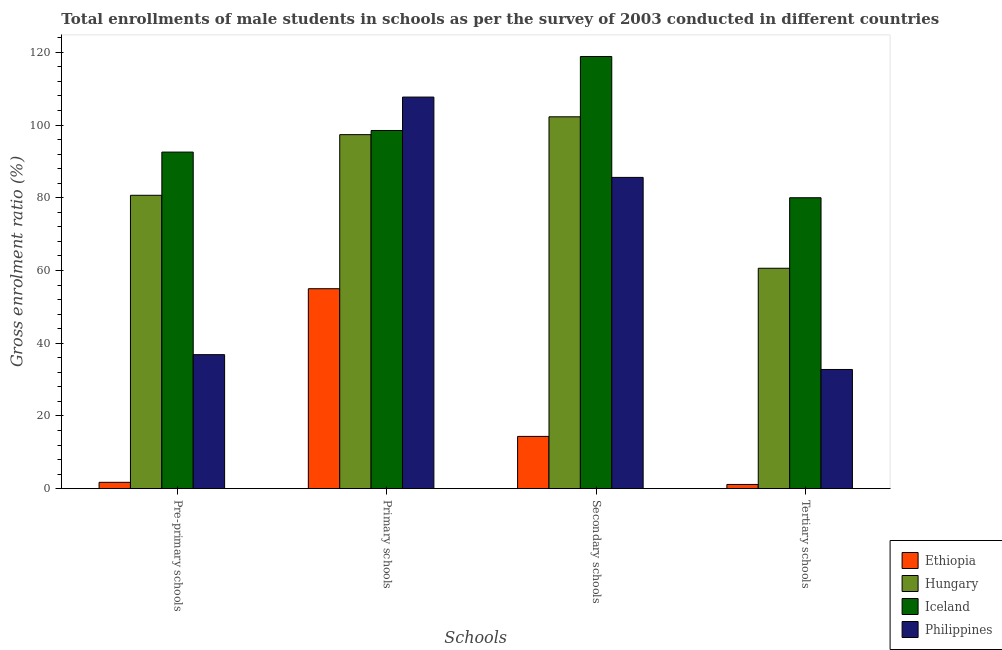Are the number of bars per tick equal to the number of legend labels?
Give a very brief answer. Yes. Are the number of bars on each tick of the X-axis equal?
Offer a very short reply. Yes. How many bars are there on the 3rd tick from the left?
Your answer should be very brief. 4. What is the label of the 1st group of bars from the left?
Make the answer very short. Pre-primary schools. What is the gross enrolment ratio(male) in secondary schools in Philippines?
Offer a very short reply. 85.6. Across all countries, what is the maximum gross enrolment ratio(male) in primary schools?
Ensure brevity in your answer.  107.69. Across all countries, what is the minimum gross enrolment ratio(male) in pre-primary schools?
Keep it short and to the point. 1.75. In which country was the gross enrolment ratio(male) in secondary schools maximum?
Give a very brief answer. Iceland. In which country was the gross enrolment ratio(male) in tertiary schools minimum?
Offer a terse response. Ethiopia. What is the total gross enrolment ratio(male) in primary schools in the graph?
Provide a short and direct response. 358.55. What is the difference between the gross enrolment ratio(male) in secondary schools in Ethiopia and that in Philippines?
Offer a very short reply. -71.23. What is the difference between the gross enrolment ratio(male) in secondary schools in Philippines and the gross enrolment ratio(male) in pre-primary schools in Iceland?
Keep it short and to the point. -6.96. What is the average gross enrolment ratio(male) in secondary schools per country?
Provide a succinct answer. 80.28. What is the difference between the gross enrolment ratio(male) in tertiary schools and gross enrolment ratio(male) in primary schools in Philippines?
Keep it short and to the point. -74.91. In how many countries, is the gross enrolment ratio(male) in primary schools greater than 72 %?
Your answer should be very brief. 3. What is the ratio of the gross enrolment ratio(male) in primary schools in Philippines to that in Iceland?
Provide a short and direct response. 1.09. Is the difference between the gross enrolment ratio(male) in tertiary schools in Ethiopia and Hungary greater than the difference between the gross enrolment ratio(male) in secondary schools in Ethiopia and Hungary?
Provide a short and direct response. Yes. What is the difference between the highest and the second highest gross enrolment ratio(male) in primary schools?
Your response must be concise. 9.19. What is the difference between the highest and the lowest gross enrolment ratio(male) in tertiary schools?
Ensure brevity in your answer.  78.85. What does the 2nd bar from the left in Pre-primary schools represents?
Make the answer very short. Hungary. What does the 1st bar from the right in Primary schools represents?
Ensure brevity in your answer.  Philippines. Is it the case that in every country, the sum of the gross enrolment ratio(male) in pre-primary schools and gross enrolment ratio(male) in primary schools is greater than the gross enrolment ratio(male) in secondary schools?
Your response must be concise. Yes. How many bars are there?
Keep it short and to the point. 16. Are all the bars in the graph horizontal?
Give a very brief answer. No. What is the difference between two consecutive major ticks on the Y-axis?
Your answer should be very brief. 20. Does the graph contain any zero values?
Offer a terse response. No. What is the title of the graph?
Offer a very short reply. Total enrollments of male students in schools as per the survey of 2003 conducted in different countries. Does "Uruguay" appear as one of the legend labels in the graph?
Offer a terse response. No. What is the label or title of the X-axis?
Provide a short and direct response. Schools. What is the label or title of the Y-axis?
Provide a succinct answer. Gross enrolment ratio (%). What is the Gross enrolment ratio (%) in Ethiopia in Pre-primary schools?
Your answer should be compact. 1.75. What is the Gross enrolment ratio (%) in Hungary in Pre-primary schools?
Provide a short and direct response. 80.68. What is the Gross enrolment ratio (%) of Iceland in Pre-primary schools?
Ensure brevity in your answer.  92.56. What is the Gross enrolment ratio (%) in Philippines in Pre-primary schools?
Keep it short and to the point. 36.86. What is the Gross enrolment ratio (%) in Ethiopia in Primary schools?
Ensure brevity in your answer.  54.99. What is the Gross enrolment ratio (%) in Hungary in Primary schools?
Make the answer very short. 97.36. What is the Gross enrolment ratio (%) of Iceland in Primary schools?
Offer a terse response. 98.51. What is the Gross enrolment ratio (%) in Philippines in Primary schools?
Make the answer very short. 107.69. What is the Gross enrolment ratio (%) in Ethiopia in Secondary schools?
Make the answer very short. 14.38. What is the Gross enrolment ratio (%) of Hungary in Secondary schools?
Your answer should be compact. 102.27. What is the Gross enrolment ratio (%) in Iceland in Secondary schools?
Offer a terse response. 118.85. What is the Gross enrolment ratio (%) of Philippines in Secondary schools?
Make the answer very short. 85.6. What is the Gross enrolment ratio (%) of Ethiopia in Tertiary schools?
Make the answer very short. 1.16. What is the Gross enrolment ratio (%) in Hungary in Tertiary schools?
Keep it short and to the point. 60.61. What is the Gross enrolment ratio (%) in Iceland in Tertiary schools?
Provide a succinct answer. 80.01. What is the Gross enrolment ratio (%) in Philippines in Tertiary schools?
Offer a very short reply. 32.78. Across all Schools, what is the maximum Gross enrolment ratio (%) of Ethiopia?
Your answer should be compact. 54.99. Across all Schools, what is the maximum Gross enrolment ratio (%) of Hungary?
Offer a terse response. 102.27. Across all Schools, what is the maximum Gross enrolment ratio (%) of Iceland?
Your answer should be very brief. 118.85. Across all Schools, what is the maximum Gross enrolment ratio (%) in Philippines?
Offer a terse response. 107.69. Across all Schools, what is the minimum Gross enrolment ratio (%) of Ethiopia?
Your answer should be compact. 1.16. Across all Schools, what is the minimum Gross enrolment ratio (%) in Hungary?
Keep it short and to the point. 60.61. Across all Schools, what is the minimum Gross enrolment ratio (%) of Iceland?
Provide a short and direct response. 80.01. Across all Schools, what is the minimum Gross enrolment ratio (%) of Philippines?
Provide a succinct answer. 32.78. What is the total Gross enrolment ratio (%) of Ethiopia in the graph?
Make the answer very short. 72.27. What is the total Gross enrolment ratio (%) in Hungary in the graph?
Ensure brevity in your answer.  340.92. What is the total Gross enrolment ratio (%) in Iceland in the graph?
Offer a very short reply. 389.93. What is the total Gross enrolment ratio (%) in Philippines in the graph?
Your answer should be compact. 262.94. What is the difference between the Gross enrolment ratio (%) in Ethiopia in Pre-primary schools and that in Primary schools?
Give a very brief answer. -53.24. What is the difference between the Gross enrolment ratio (%) in Hungary in Pre-primary schools and that in Primary schools?
Ensure brevity in your answer.  -16.68. What is the difference between the Gross enrolment ratio (%) of Iceland in Pre-primary schools and that in Primary schools?
Give a very brief answer. -5.94. What is the difference between the Gross enrolment ratio (%) in Philippines in Pre-primary schools and that in Primary schools?
Offer a very short reply. -70.83. What is the difference between the Gross enrolment ratio (%) in Ethiopia in Pre-primary schools and that in Secondary schools?
Offer a very short reply. -12.63. What is the difference between the Gross enrolment ratio (%) in Hungary in Pre-primary schools and that in Secondary schools?
Make the answer very short. -21.58. What is the difference between the Gross enrolment ratio (%) of Iceland in Pre-primary schools and that in Secondary schools?
Provide a succinct answer. -26.29. What is the difference between the Gross enrolment ratio (%) in Philippines in Pre-primary schools and that in Secondary schools?
Provide a succinct answer. -48.74. What is the difference between the Gross enrolment ratio (%) in Ethiopia in Pre-primary schools and that in Tertiary schools?
Provide a succinct answer. 0.59. What is the difference between the Gross enrolment ratio (%) in Hungary in Pre-primary schools and that in Tertiary schools?
Your answer should be very brief. 20.07. What is the difference between the Gross enrolment ratio (%) of Iceland in Pre-primary schools and that in Tertiary schools?
Keep it short and to the point. 12.55. What is the difference between the Gross enrolment ratio (%) in Philippines in Pre-primary schools and that in Tertiary schools?
Give a very brief answer. 4.08. What is the difference between the Gross enrolment ratio (%) in Ethiopia in Primary schools and that in Secondary schools?
Your answer should be very brief. 40.61. What is the difference between the Gross enrolment ratio (%) of Hungary in Primary schools and that in Secondary schools?
Make the answer very short. -4.91. What is the difference between the Gross enrolment ratio (%) in Iceland in Primary schools and that in Secondary schools?
Your response must be concise. -20.35. What is the difference between the Gross enrolment ratio (%) in Philippines in Primary schools and that in Secondary schools?
Your answer should be very brief. 22.09. What is the difference between the Gross enrolment ratio (%) in Ethiopia in Primary schools and that in Tertiary schools?
Offer a terse response. 53.83. What is the difference between the Gross enrolment ratio (%) in Hungary in Primary schools and that in Tertiary schools?
Your answer should be very brief. 36.74. What is the difference between the Gross enrolment ratio (%) of Iceland in Primary schools and that in Tertiary schools?
Ensure brevity in your answer.  18.5. What is the difference between the Gross enrolment ratio (%) in Philippines in Primary schools and that in Tertiary schools?
Offer a very short reply. 74.91. What is the difference between the Gross enrolment ratio (%) of Ethiopia in Secondary schools and that in Tertiary schools?
Provide a short and direct response. 13.22. What is the difference between the Gross enrolment ratio (%) in Hungary in Secondary schools and that in Tertiary schools?
Provide a succinct answer. 41.65. What is the difference between the Gross enrolment ratio (%) of Iceland in Secondary schools and that in Tertiary schools?
Your answer should be very brief. 38.84. What is the difference between the Gross enrolment ratio (%) in Philippines in Secondary schools and that in Tertiary schools?
Give a very brief answer. 52.82. What is the difference between the Gross enrolment ratio (%) in Ethiopia in Pre-primary schools and the Gross enrolment ratio (%) in Hungary in Primary schools?
Your answer should be compact. -95.61. What is the difference between the Gross enrolment ratio (%) in Ethiopia in Pre-primary schools and the Gross enrolment ratio (%) in Iceland in Primary schools?
Offer a terse response. -96.76. What is the difference between the Gross enrolment ratio (%) of Ethiopia in Pre-primary schools and the Gross enrolment ratio (%) of Philippines in Primary schools?
Provide a succinct answer. -105.95. What is the difference between the Gross enrolment ratio (%) in Hungary in Pre-primary schools and the Gross enrolment ratio (%) in Iceland in Primary schools?
Your answer should be compact. -17.83. What is the difference between the Gross enrolment ratio (%) in Hungary in Pre-primary schools and the Gross enrolment ratio (%) in Philippines in Primary schools?
Give a very brief answer. -27.01. What is the difference between the Gross enrolment ratio (%) in Iceland in Pre-primary schools and the Gross enrolment ratio (%) in Philippines in Primary schools?
Ensure brevity in your answer.  -15.13. What is the difference between the Gross enrolment ratio (%) of Ethiopia in Pre-primary schools and the Gross enrolment ratio (%) of Hungary in Secondary schools?
Give a very brief answer. -100.52. What is the difference between the Gross enrolment ratio (%) of Ethiopia in Pre-primary schools and the Gross enrolment ratio (%) of Iceland in Secondary schools?
Your response must be concise. -117.11. What is the difference between the Gross enrolment ratio (%) of Ethiopia in Pre-primary schools and the Gross enrolment ratio (%) of Philippines in Secondary schools?
Ensure brevity in your answer.  -83.86. What is the difference between the Gross enrolment ratio (%) in Hungary in Pre-primary schools and the Gross enrolment ratio (%) in Iceland in Secondary schools?
Give a very brief answer. -38.17. What is the difference between the Gross enrolment ratio (%) of Hungary in Pre-primary schools and the Gross enrolment ratio (%) of Philippines in Secondary schools?
Provide a short and direct response. -4.92. What is the difference between the Gross enrolment ratio (%) in Iceland in Pre-primary schools and the Gross enrolment ratio (%) in Philippines in Secondary schools?
Offer a terse response. 6.96. What is the difference between the Gross enrolment ratio (%) in Ethiopia in Pre-primary schools and the Gross enrolment ratio (%) in Hungary in Tertiary schools?
Provide a short and direct response. -58.87. What is the difference between the Gross enrolment ratio (%) of Ethiopia in Pre-primary schools and the Gross enrolment ratio (%) of Iceland in Tertiary schools?
Offer a terse response. -78.26. What is the difference between the Gross enrolment ratio (%) of Ethiopia in Pre-primary schools and the Gross enrolment ratio (%) of Philippines in Tertiary schools?
Your response must be concise. -31.03. What is the difference between the Gross enrolment ratio (%) of Hungary in Pre-primary schools and the Gross enrolment ratio (%) of Iceland in Tertiary schools?
Your response must be concise. 0.67. What is the difference between the Gross enrolment ratio (%) in Hungary in Pre-primary schools and the Gross enrolment ratio (%) in Philippines in Tertiary schools?
Ensure brevity in your answer.  47.9. What is the difference between the Gross enrolment ratio (%) in Iceland in Pre-primary schools and the Gross enrolment ratio (%) in Philippines in Tertiary schools?
Your response must be concise. 59.78. What is the difference between the Gross enrolment ratio (%) in Ethiopia in Primary schools and the Gross enrolment ratio (%) in Hungary in Secondary schools?
Your response must be concise. -47.27. What is the difference between the Gross enrolment ratio (%) in Ethiopia in Primary schools and the Gross enrolment ratio (%) in Iceland in Secondary schools?
Offer a very short reply. -63.86. What is the difference between the Gross enrolment ratio (%) of Ethiopia in Primary schools and the Gross enrolment ratio (%) of Philippines in Secondary schools?
Your answer should be compact. -30.61. What is the difference between the Gross enrolment ratio (%) in Hungary in Primary schools and the Gross enrolment ratio (%) in Iceland in Secondary schools?
Make the answer very short. -21.5. What is the difference between the Gross enrolment ratio (%) in Hungary in Primary schools and the Gross enrolment ratio (%) in Philippines in Secondary schools?
Your answer should be compact. 11.76. What is the difference between the Gross enrolment ratio (%) of Iceland in Primary schools and the Gross enrolment ratio (%) of Philippines in Secondary schools?
Make the answer very short. 12.9. What is the difference between the Gross enrolment ratio (%) of Ethiopia in Primary schools and the Gross enrolment ratio (%) of Hungary in Tertiary schools?
Make the answer very short. -5.62. What is the difference between the Gross enrolment ratio (%) in Ethiopia in Primary schools and the Gross enrolment ratio (%) in Iceland in Tertiary schools?
Keep it short and to the point. -25.02. What is the difference between the Gross enrolment ratio (%) in Ethiopia in Primary schools and the Gross enrolment ratio (%) in Philippines in Tertiary schools?
Your response must be concise. 22.21. What is the difference between the Gross enrolment ratio (%) of Hungary in Primary schools and the Gross enrolment ratio (%) of Iceland in Tertiary schools?
Provide a succinct answer. 17.35. What is the difference between the Gross enrolment ratio (%) of Hungary in Primary schools and the Gross enrolment ratio (%) of Philippines in Tertiary schools?
Ensure brevity in your answer.  64.58. What is the difference between the Gross enrolment ratio (%) of Iceland in Primary schools and the Gross enrolment ratio (%) of Philippines in Tertiary schools?
Offer a very short reply. 65.73. What is the difference between the Gross enrolment ratio (%) of Ethiopia in Secondary schools and the Gross enrolment ratio (%) of Hungary in Tertiary schools?
Give a very brief answer. -46.24. What is the difference between the Gross enrolment ratio (%) of Ethiopia in Secondary schools and the Gross enrolment ratio (%) of Iceland in Tertiary schools?
Your response must be concise. -65.63. What is the difference between the Gross enrolment ratio (%) of Ethiopia in Secondary schools and the Gross enrolment ratio (%) of Philippines in Tertiary schools?
Offer a terse response. -18.4. What is the difference between the Gross enrolment ratio (%) in Hungary in Secondary schools and the Gross enrolment ratio (%) in Iceland in Tertiary schools?
Make the answer very short. 22.26. What is the difference between the Gross enrolment ratio (%) of Hungary in Secondary schools and the Gross enrolment ratio (%) of Philippines in Tertiary schools?
Ensure brevity in your answer.  69.48. What is the difference between the Gross enrolment ratio (%) in Iceland in Secondary schools and the Gross enrolment ratio (%) in Philippines in Tertiary schools?
Your response must be concise. 86.07. What is the average Gross enrolment ratio (%) in Ethiopia per Schools?
Ensure brevity in your answer.  18.07. What is the average Gross enrolment ratio (%) in Hungary per Schools?
Keep it short and to the point. 85.23. What is the average Gross enrolment ratio (%) of Iceland per Schools?
Your answer should be compact. 97.48. What is the average Gross enrolment ratio (%) in Philippines per Schools?
Provide a short and direct response. 65.73. What is the difference between the Gross enrolment ratio (%) in Ethiopia and Gross enrolment ratio (%) in Hungary in Pre-primary schools?
Offer a very short reply. -78.94. What is the difference between the Gross enrolment ratio (%) in Ethiopia and Gross enrolment ratio (%) in Iceland in Pre-primary schools?
Offer a terse response. -90.82. What is the difference between the Gross enrolment ratio (%) in Ethiopia and Gross enrolment ratio (%) in Philippines in Pre-primary schools?
Offer a terse response. -35.11. What is the difference between the Gross enrolment ratio (%) in Hungary and Gross enrolment ratio (%) in Iceland in Pre-primary schools?
Ensure brevity in your answer.  -11.88. What is the difference between the Gross enrolment ratio (%) of Hungary and Gross enrolment ratio (%) of Philippines in Pre-primary schools?
Provide a short and direct response. 43.82. What is the difference between the Gross enrolment ratio (%) of Iceland and Gross enrolment ratio (%) of Philippines in Pre-primary schools?
Provide a short and direct response. 55.7. What is the difference between the Gross enrolment ratio (%) in Ethiopia and Gross enrolment ratio (%) in Hungary in Primary schools?
Offer a very short reply. -42.37. What is the difference between the Gross enrolment ratio (%) in Ethiopia and Gross enrolment ratio (%) in Iceland in Primary schools?
Your answer should be compact. -43.52. What is the difference between the Gross enrolment ratio (%) of Ethiopia and Gross enrolment ratio (%) of Philippines in Primary schools?
Give a very brief answer. -52.7. What is the difference between the Gross enrolment ratio (%) in Hungary and Gross enrolment ratio (%) in Iceland in Primary schools?
Provide a succinct answer. -1.15. What is the difference between the Gross enrolment ratio (%) in Hungary and Gross enrolment ratio (%) in Philippines in Primary schools?
Offer a terse response. -10.34. What is the difference between the Gross enrolment ratio (%) of Iceland and Gross enrolment ratio (%) of Philippines in Primary schools?
Offer a terse response. -9.19. What is the difference between the Gross enrolment ratio (%) in Ethiopia and Gross enrolment ratio (%) in Hungary in Secondary schools?
Keep it short and to the point. -87.89. What is the difference between the Gross enrolment ratio (%) of Ethiopia and Gross enrolment ratio (%) of Iceland in Secondary schools?
Provide a succinct answer. -104.48. What is the difference between the Gross enrolment ratio (%) of Ethiopia and Gross enrolment ratio (%) of Philippines in Secondary schools?
Provide a short and direct response. -71.23. What is the difference between the Gross enrolment ratio (%) in Hungary and Gross enrolment ratio (%) in Iceland in Secondary schools?
Offer a terse response. -16.59. What is the difference between the Gross enrolment ratio (%) in Hungary and Gross enrolment ratio (%) in Philippines in Secondary schools?
Ensure brevity in your answer.  16.66. What is the difference between the Gross enrolment ratio (%) of Iceland and Gross enrolment ratio (%) of Philippines in Secondary schools?
Provide a short and direct response. 33.25. What is the difference between the Gross enrolment ratio (%) of Ethiopia and Gross enrolment ratio (%) of Hungary in Tertiary schools?
Offer a terse response. -59.46. What is the difference between the Gross enrolment ratio (%) of Ethiopia and Gross enrolment ratio (%) of Iceland in Tertiary schools?
Make the answer very short. -78.85. What is the difference between the Gross enrolment ratio (%) of Ethiopia and Gross enrolment ratio (%) of Philippines in Tertiary schools?
Keep it short and to the point. -31.62. What is the difference between the Gross enrolment ratio (%) of Hungary and Gross enrolment ratio (%) of Iceland in Tertiary schools?
Your response must be concise. -19.39. What is the difference between the Gross enrolment ratio (%) of Hungary and Gross enrolment ratio (%) of Philippines in Tertiary schools?
Make the answer very short. 27.83. What is the difference between the Gross enrolment ratio (%) of Iceland and Gross enrolment ratio (%) of Philippines in Tertiary schools?
Ensure brevity in your answer.  47.23. What is the ratio of the Gross enrolment ratio (%) of Ethiopia in Pre-primary schools to that in Primary schools?
Ensure brevity in your answer.  0.03. What is the ratio of the Gross enrolment ratio (%) in Hungary in Pre-primary schools to that in Primary schools?
Give a very brief answer. 0.83. What is the ratio of the Gross enrolment ratio (%) of Iceland in Pre-primary schools to that in Primary schools?
Offer a terse response. 0.94. What is the ratio of the Gross enrolment ratio (%) of Philippines in Pre-primary schools to that in Primary schools?
Offer a very short reply. 0.34. What is the ratio of the Gross enrolment ratio (%) in Ethiopia in Pre-primary schools to that in Secondary schools?
Keep it short and to the point. 0.12. What is the ratio of the Gross enrolment ratio (%) in Hungary in Pre-primary schools to that in Secondary schools?
Your response must be concise. 0.79. What is the ratio of the Gross enrolment ratio (%) in Iceland in Pre-primary schools to that in Secondary schools?
Provide a short and direct response. 0.78. What is the ratio of the Gross enrolment ratio (%) in Philippines in Pre-primary schools to that in Secondary schools?
Your answer should be very brief. 0.43. What is the ratio of the Gross enrolment ratio (%) in Ethiopia in Pre-primary schools to that in Tertiary schools?
Keep it short and to the point. 1.51. What is the ratio of the Gross enrolment ratio (%) in Hungary in Pre-primary schools to that in Tertiary schools?
Make the answer very short. 1.33. What is the ratio of the Gross enrolment ratio (%) in Iceland in Pre-primary schools to that in Tertiary schools?
Offer a terse response. 1.16. What is the ratio of the Gross enrolment ratio (%) in Philippines in Pre-primary schools to that in Tertiary schools?
Offer a terse response. 1.12. What is the ratio of the Gross enrolment ratio (%) in Ethiopia in Primary schools to that in Secondary schools?
Ensure brevity in your answer.  3.82. What is the ratio of the Gross enrolment ratio (%) of Iceland in Primary schools to that in Secondary schools?
Your answer should be very brief. 0.83. What is the ratio of the Gross enrolment ratio (%) of Philippines in Primary schools to that in Secondary schools?
Your answer should be compact. 1.26. What is the ratio of the Gross enrolment ratio (%) of Ethiopia in Primary schools to that in Tertiary schools?
Give a very brief answer. 47.49. What is the ratio of the Gross enrolment ratio (%) of Hungary in Primary schools to that in Tertiary schools?
Give a very brief answer. 1.61. What is the ratio of the Gross enrolment ratio (%) of Iceland in Primary schools to that in Tertiary schools?
Your answer should be compact. 1.23. What is the ratio of the Gross enrolment ratio (%) in Philippines in Primary schools to that in Tertiary schools?
Provide a succinct answer. 3.29. What is the ratio of the Gross enrolment ratio (%) in Ethiopia in Secondary schools to that in Tertiary schools?
Ensure brevity in your answer.  12.42. What is the ratio of the Gross enrolment ratio (%) of Hungary in Secondary schools to that in Tertiary schools?
Offer a very short reply. 1.69. What is the ratio of the Gross enrolment ratio (%) of Iceland in Secondary schools to that in Tertiary schools?
Keep it short and to the point. 1.49. What is the ratio of the Gross enrolment ratio (%) in Philippines in Secondary schools to that in Tertiary schools?
Your answer should be very brief. 2.61. What is the difference between the highest and the second highest Gross enrolment ratio (%) in Ethiopia?
Your response must be concise. 40.61. What is the difference between the highest and the second highest Gross enrolment ratio (%) in Hungary?
Make the answer very short. 4.91. What is the difference between the highest and the second highest Gross enrolment ratio (%) in Iceland?
Your response must be concise. 20.35. What is the difference between the highest and the second highest Gross enrolment ratio (%) of Philippines?
Provide a succinct answer. 22.09. What is the difference between the highest and the lowest Gross enrolment ratio (%) of Ethiopia?
Your answer should be very brief. 53.83. What is the difference between the highest and the lowest Gross enrolment ratio (%) of Hungary?
Your response must be concise. 41.65. What is the difference between the highest and the lowest Gross enrolment ratio (%) in Iceland?
Provide a succinct answer. 38.84. What is the difference between the highest and the lowest Gross enrolment ratio (%) of Philippines?
Make the answer very short. 74.91. 